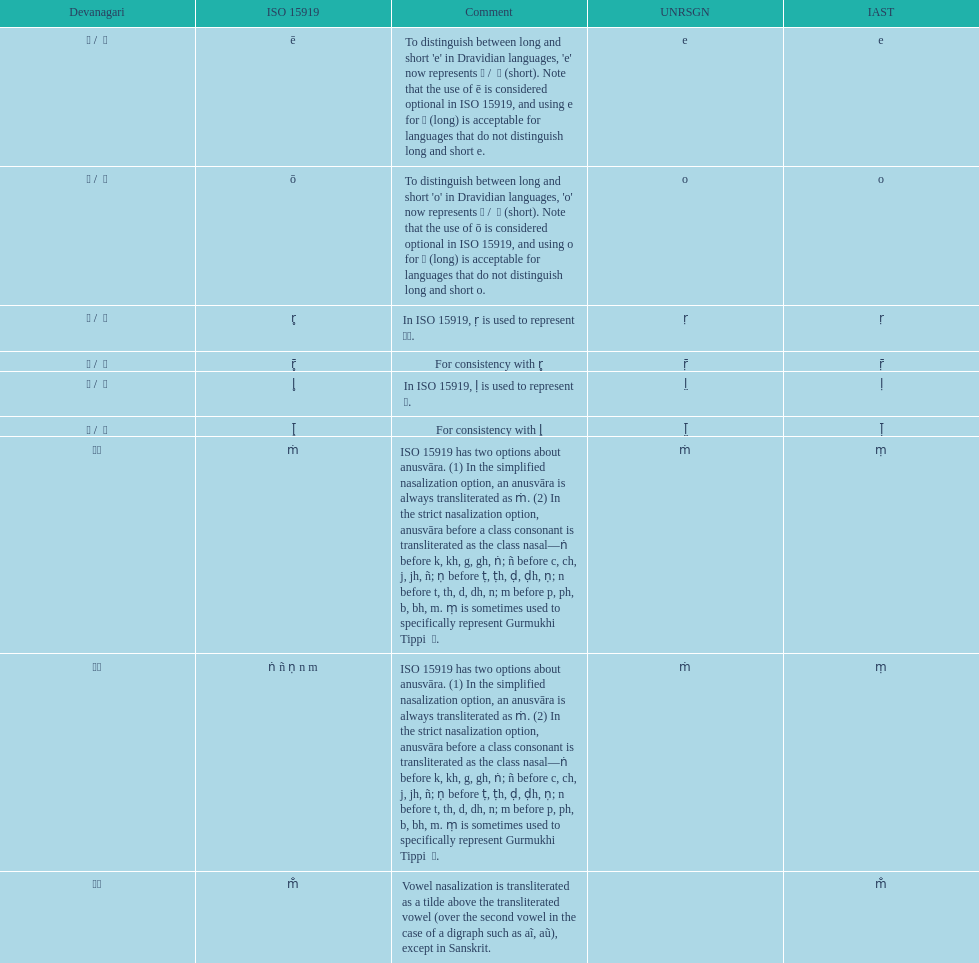Which devanagari transliteration is listed on the top of the table? ए / े. 